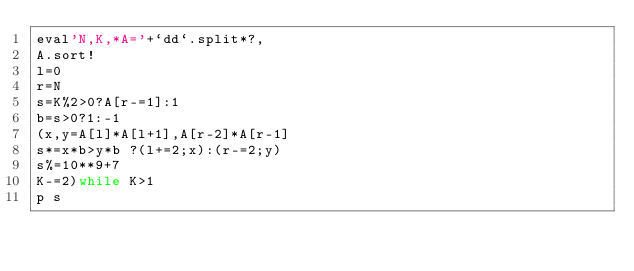<code> <loc_0><loc_0><loc_500><loc_500><_Ruby_>eval'N,K,*A='+`dd`.split*?,
A.sort!
l=0
r=N
s=K%2>0?A[r-=1]:1
b=s>0?1:-1
(x,y=A[l]*A[l+1],A[r-2]*A[r-1]
s*=x*b>y*b ?(l+=2;x):(r-=2;y)
s%=10**9+7
K-=2)while K>1
p s</code> 